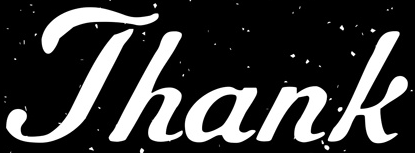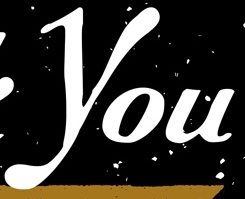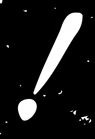Transcribe the words shown in these images in order, separated by a semicolon. Thank; You; ! 